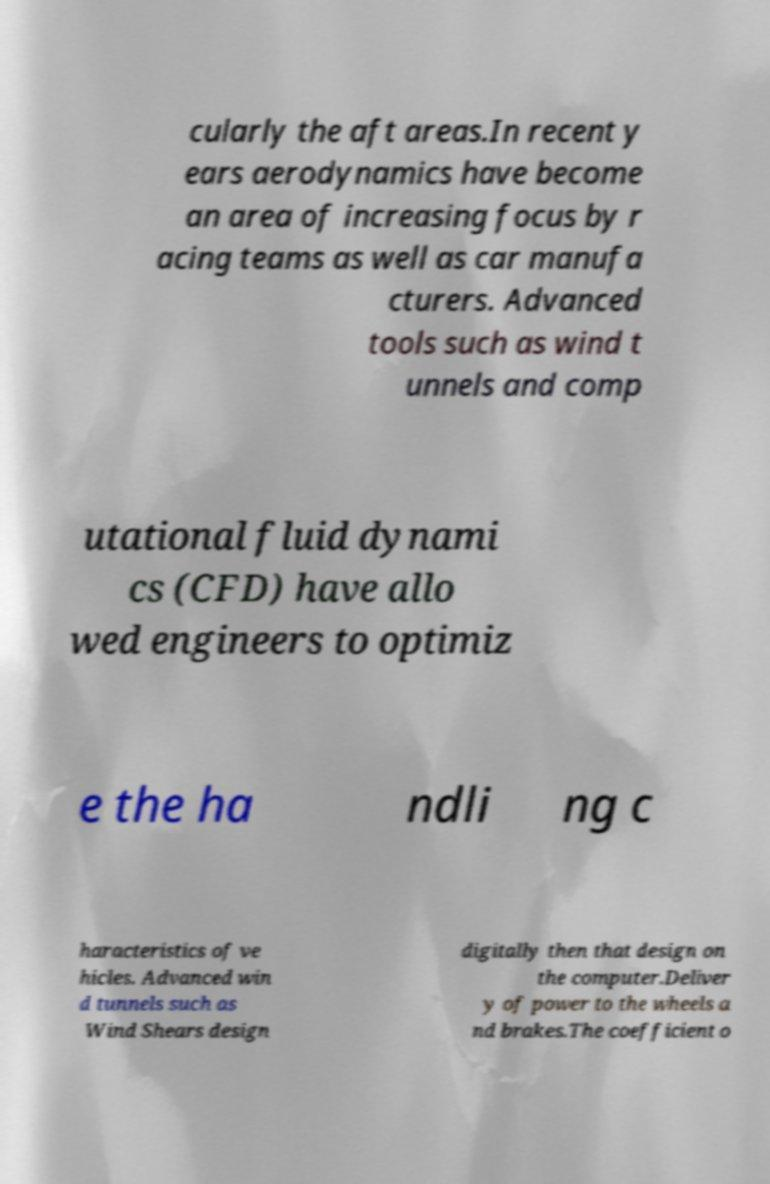Please read and relay the text visible in this image. What does it say? cularly the aft areas.In recent y ears aerodynamics have become an area of increasing focus by r acing teams as well as car manufa cturers. Advanced tools such as wind t unnels and comp utational fluid dynami cs (CFD) have allo wed engineers to optimiz e the ha ndli ng c haracteristics of ve hicles. Advanced win d tunnels such as Wind Shears design digitally then that design on the computer.Deliver y of power to the wheels a nd brakes.The coefficient o 